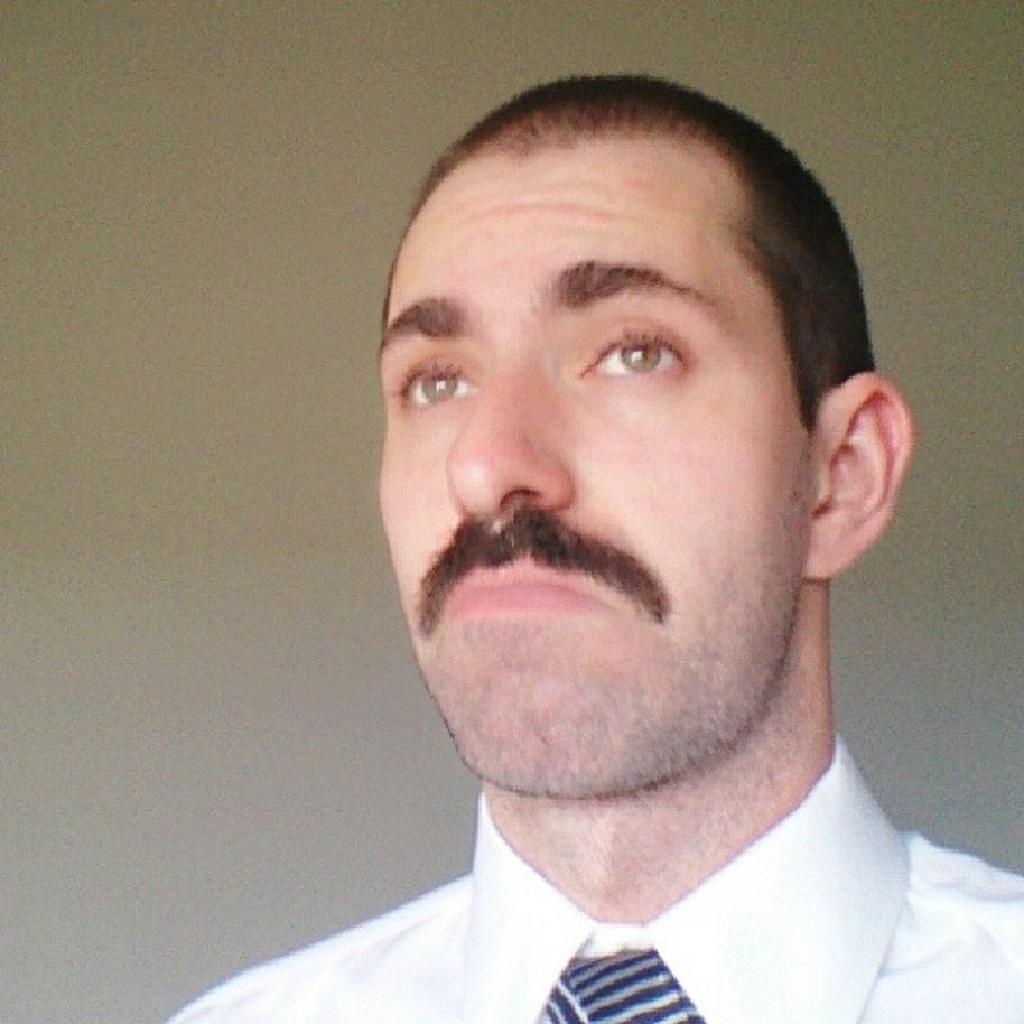What is the main subject in the foreground of the image? There is a man in the foreground of the image. What is the man wearing on his upper body? The man is wearing a white shirt. Is there any additional accessory the man is wearing? Yes, the man is wearing a tie. What can be seen in the background of the image? There is a wall in the background of the image. Can you see any wine being served near the lake in the image? There is no lake or wine present in the image; it features a man in the foreground wearing a white shirt and a tie, with a wall in the background. 